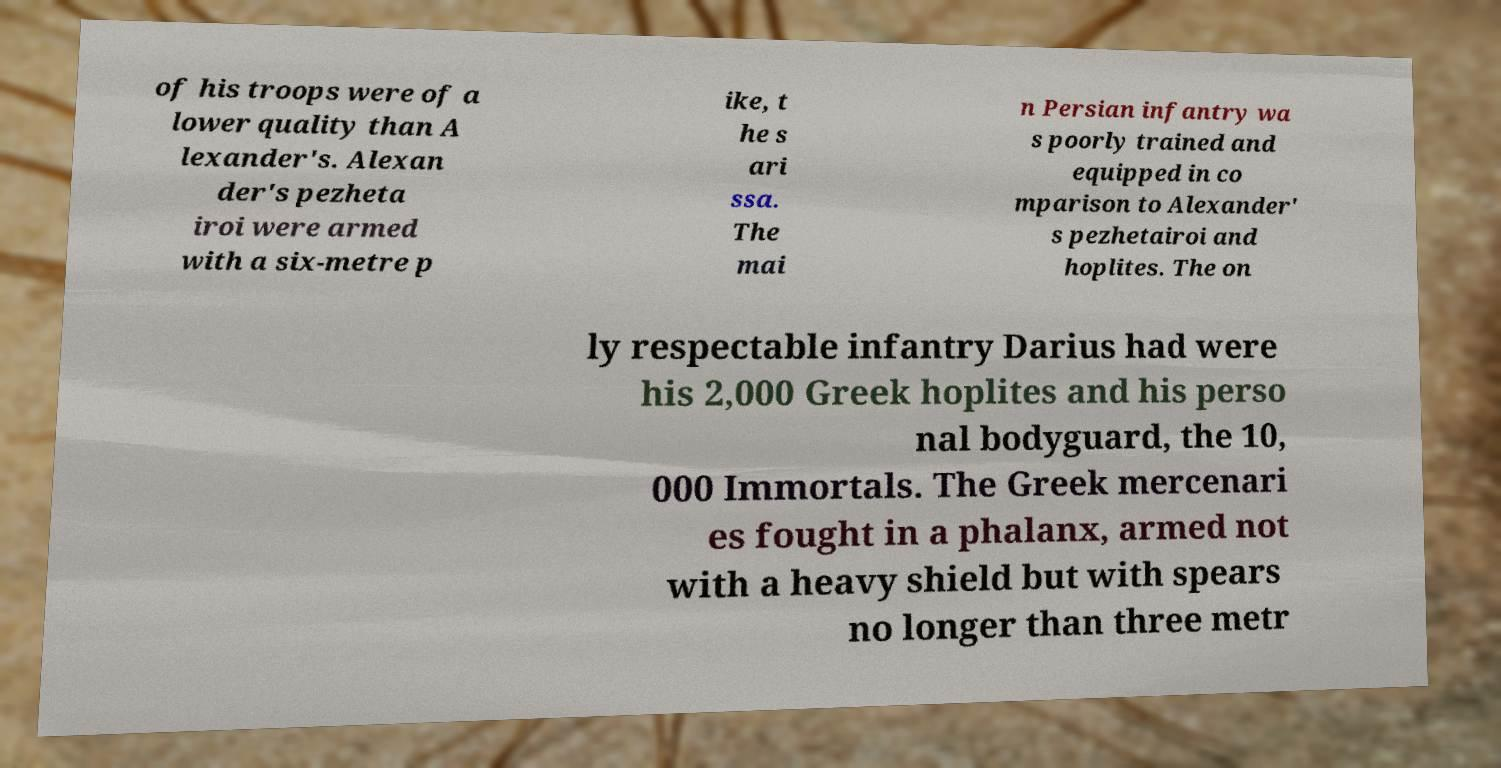Could you extract and type out the text from this image? of his troops were of a lower quality than A lexander's. Alexan der's pezheta iroi were armed with a six-metre p ike, t he s ari ssa. The mai n Persian infantry wa s poorly trained and equipped in co mparison to Alexander' s pezhetairoi and hoplites. The on ly respectable infantry Darius had were his 2,000 Greek hoplites and his perso nal bodyguard, the 10, 000 Immortals. The Greek mercenari es fought in a phalanx, armed not with a heavy shield but with spears no longer than three metr 